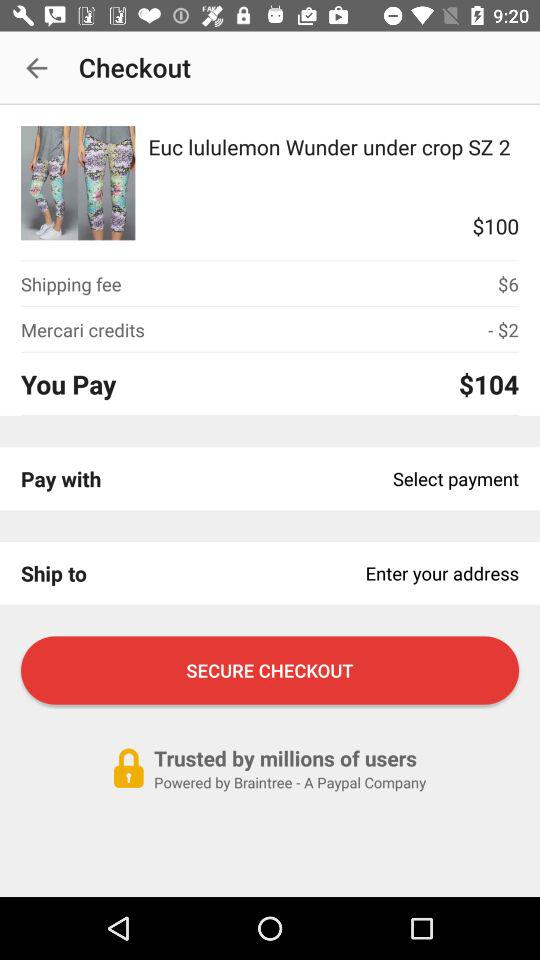How much are "Mercari" credits worth? "Mercari" credits are worth $2. 